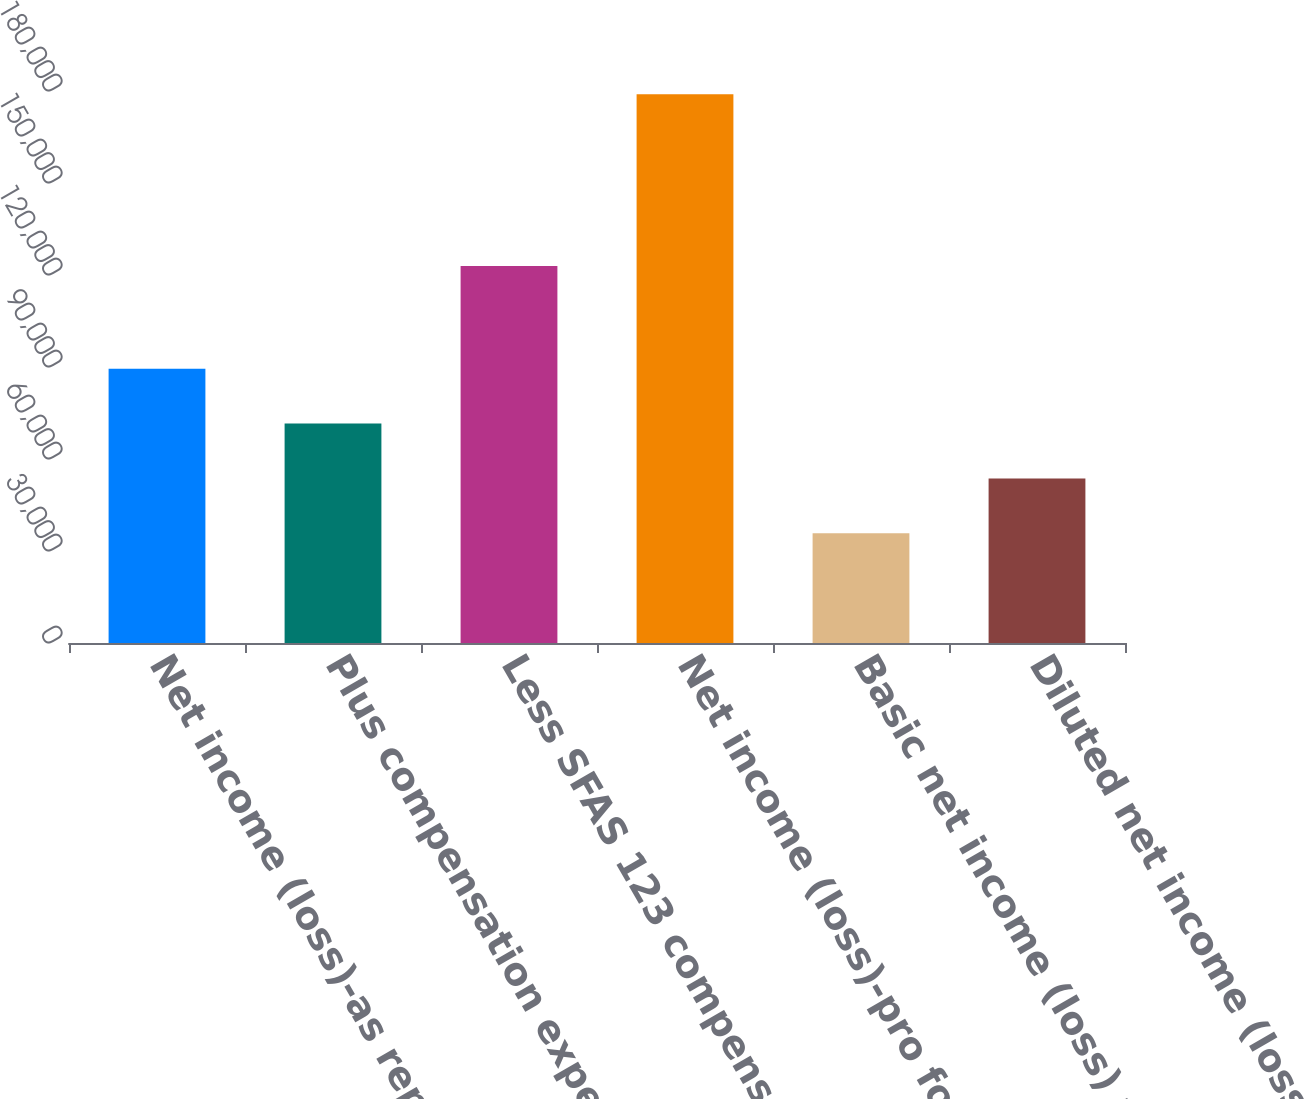Convert chart. <chart><loc_0><loc_0><loc_500><loc_500><bar_chart><fcel>Net income (loss)-as reported<fcel>Plus compensation expense<fcel>Less SFAS 123 compensation<fcel>Net income (loss)-pro forma<fcel>Basic net income (loss) per<fcel>Diluted net income (loss) per<nl><fcel>89459.1<fcel>71567.3<fcel>122929<fcel>178918<fcel>35783.7<fcel>53675.5<nl></chart> 